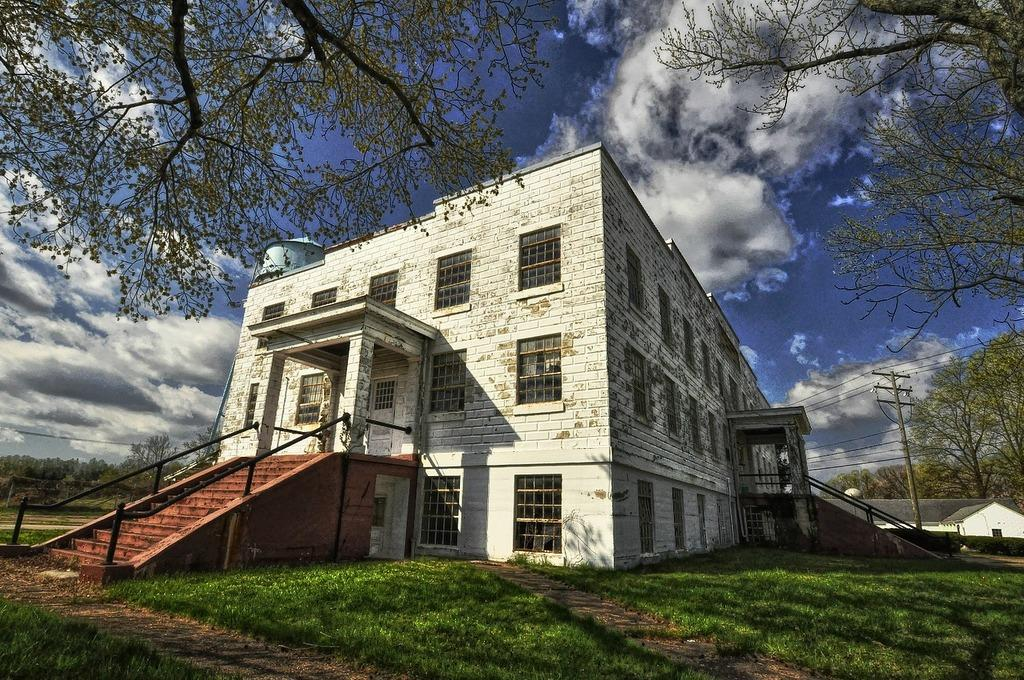What type of structures can be seen in the image? There are buildings in the image. What else can be seen besides the buildings? There is an electrical pole, trees, and grass on the ground in the image. Are there any architectural features in the image? Yes, there are stairs to climb in the image. How would you describe the sky in the image? The sky is blue and cloudy in the image. Can you see a knot tied on the electrical pole in the image? There is no knot tied on the electrical pole in the image. Is there a basketball game happening in the image? There is no basketball game or any basketball-related elements present in the image. 